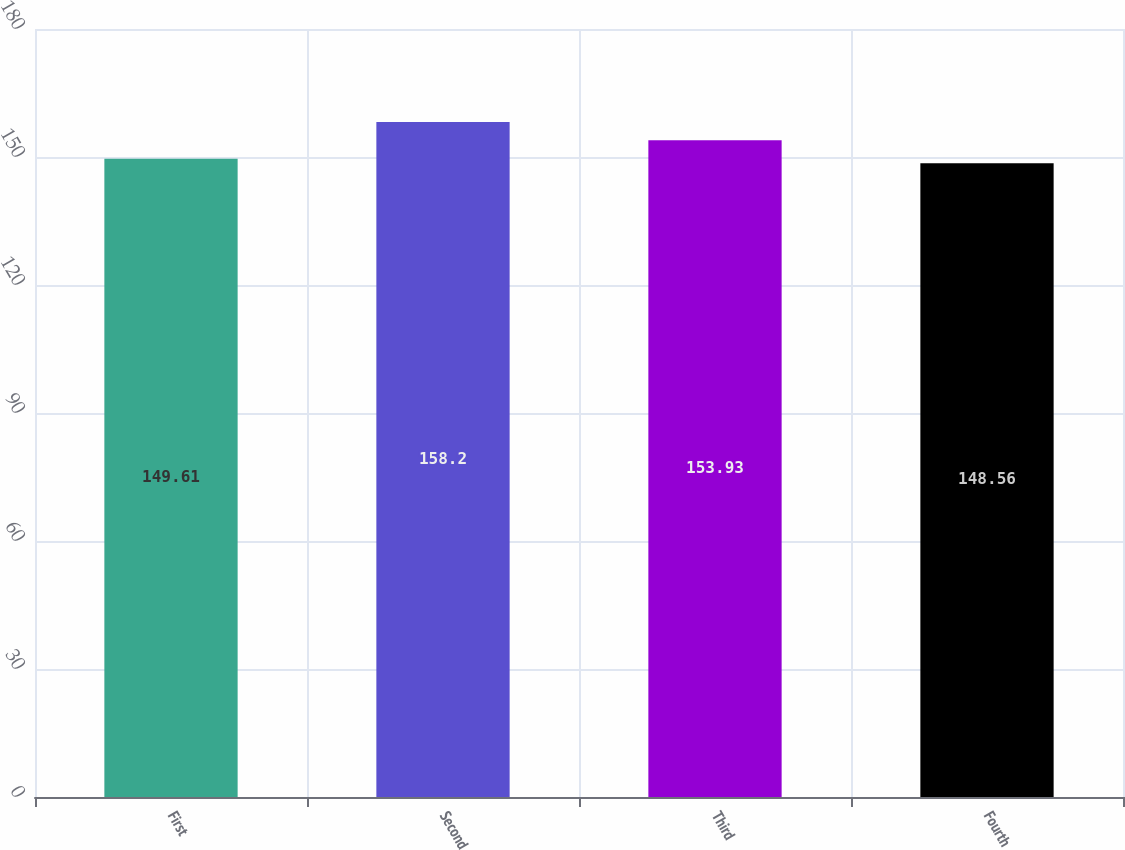Convert chart to OTSL. <chart><loc_0><loc_0><loc_500><loc_500><bar_chart><fcel>First<fcel>Second<fcel>Third<fcel>Fourth<nl><fcel>149.61<fcel>158.2<fcel>153.93<fcel>148.56<nl></chart> 